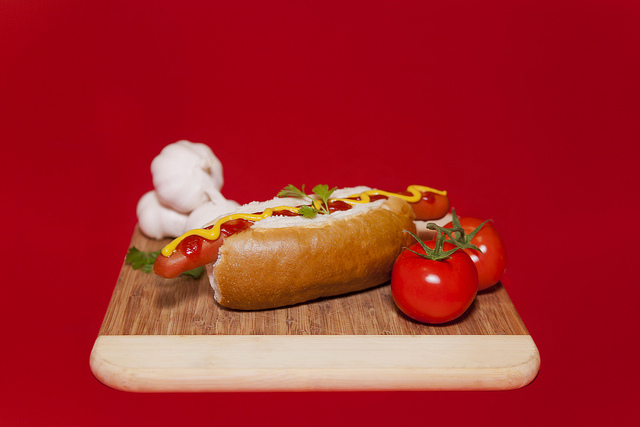Who is going to eat this hot dog? The hot dog seems perfectly prepared for a hungry person who enjoys a classic, simple yet tasty meal. 